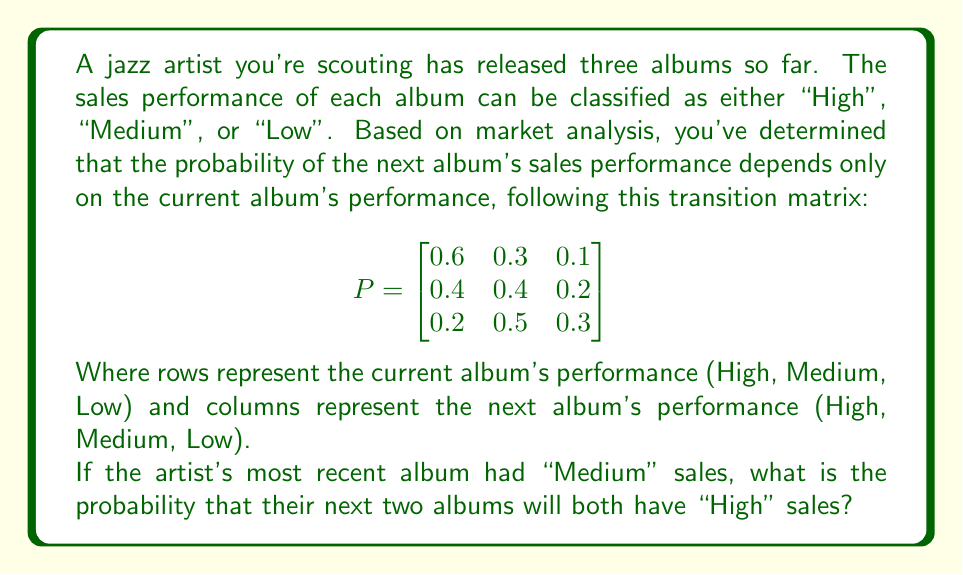Provide a solution to this math problem. To solve this problem, we'll use the Markov chain model and the given transition matrix. We'll follow these steps:

1) First, we need to find the probability of the next album having "High" sales, given that the current album had "Medium" sales.

2) Then, we'll calculate the probability of the album after that also having "High" sales, given that its predecessor had "High" sales.

3) Finally, we'll multiply these probabilities to get the joint probability of both future albums having "High" sales.

Step 1:
The probability of moving from "Medium" to "High" is given in the second row, first column of the transition matrix:

$P(\text{High} | \text{Medium}) = 0.4$

Step 2:
If the next album has "High" sales, the probability of the following album also having "High" sales is given in the first row, first column of the transition matrix:

$P(\text{High} | \text{High}) = 0.6$

Step 3:
The probability of both events occurring is the product of their individual probabilities:

$P(\text{High, High} | \text{Medium}) = P(\text{High} | \text{Medium}) \times P(\text{High} | \text{High})$

$P(\text{High, High} | \text{Medium}) = 0.4 \times 0.6 = 0.24$

Therefore, the probability that the next two albums will both have "High" sales, given that the current album had "Medium" sales, is 0.24 or 24%.
Answer: 0.24 